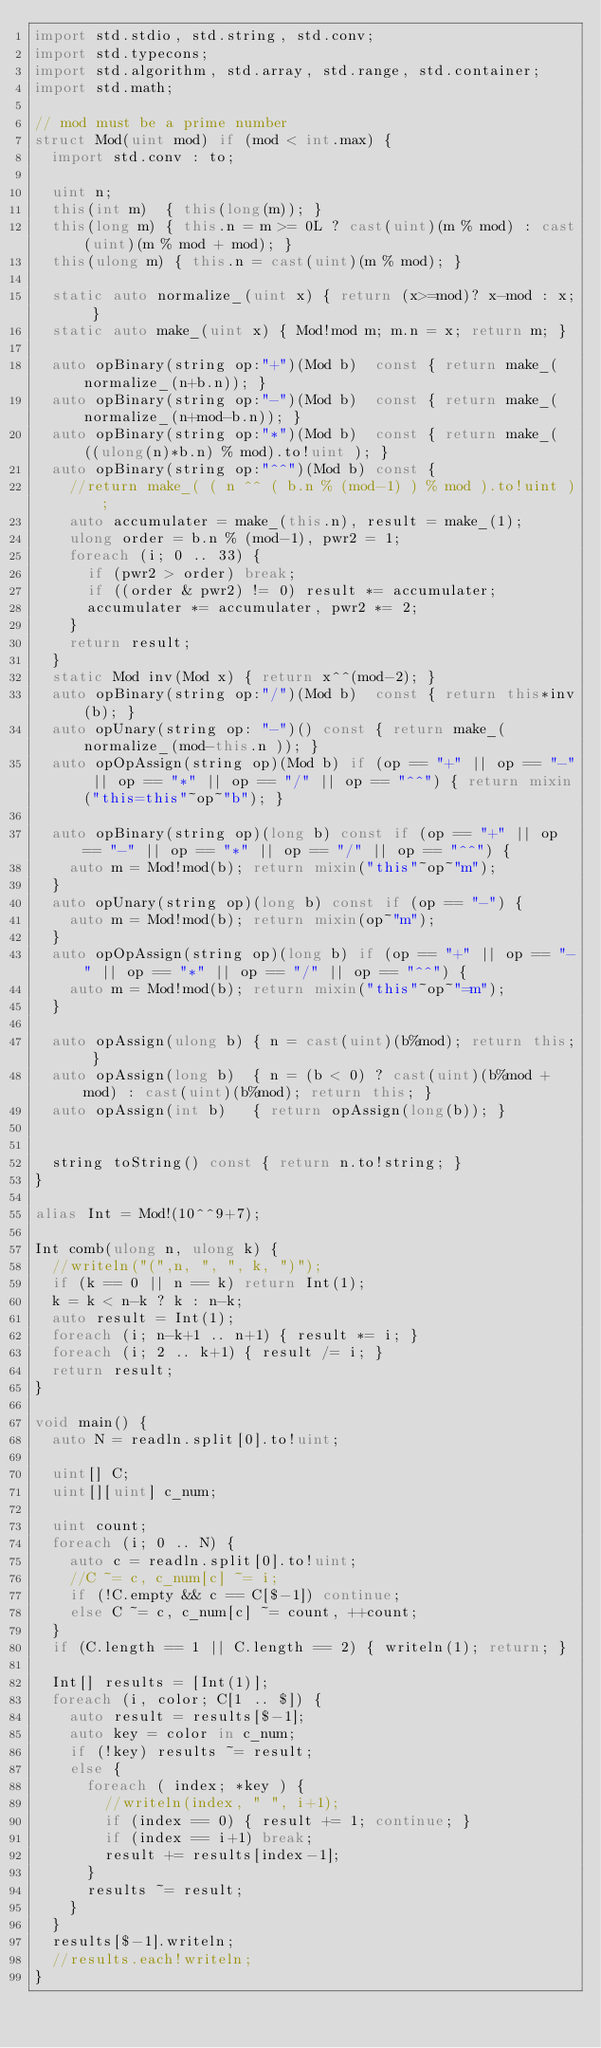<code> <loc_0><loc_0><loc_500><loc_500><_D_>import std.stdio, std.string, std.conv;
import std.typecons;
import std.algorithm, std.array, std.range, std.container;
import std.math;

// mod must be a prime number
struct Mod(uint mod) if (mod < int.max) {
	import std.conv : to;
	
	uint n;
	this(int m)  { this(long(m)); }
	this(long m) { this.n = m >= 0L ? cast(uint)(m % mod) : cast(uint)(m % mod + mod); }
	this(ulong m) { this.n = cast(uint)(m % mod); }
	
	static auto normalize_(uint x) { return (x>=mod)? x-mod : x; }
	static auto make_(uint x) { Mod!mod m; m.n = x; return m; }
	
	auto opBinary(string op:"+")(Mod b)  const { return make_(normalize_(n+b.n)); }
	auto opBinary(string op:"-")(Mod b)  const { return make_(normalize_(n+mod-b.n)); }
	auto opBinary(string op:"*")(Mod b)  const { return make_( ((ulong(n)*b.n) % mod).to!uint ); }
	auto opBinary(string op:"^^")(Mod b) const {
		//return make_( ( n ^^ ( b.n % (mod-1) ) % mod ).to!uint );
		auto accumulater = make_(this.n), result = make_(1);
		ulong order = b.n % (mod-1), pwr2 = 1;
		foreach (i; 0 .. 33) {
			if (pwr2 > order) break;
			if ((order & pwr2) != 0) result *= accumulater;
			accumulater *= accumulater, pwr2 *= 2;
		}
		return result;
	}
	static Mod inv(Mod x) { return x^^(mod-2); }
	auto opBinary(string op:"/")(Mod b)  const { return this*inv(b); }
	auto opUnary(string op: "-")() const { return make_(normalize_(mod-this.n )); }
	auto opOpAssign(string op)(Mod b) if (op == "+" || op == "-" || op == "*" || op == "/" || op == "^^") { return mixin("this=this"~op~"b"); }
	
	auto opBinary(string op)(long b) const if (op == "+" || op == "-" || op == "*" || op == "/" || op == "^^") {
		auto m = Mod!mod(b); return mixin("this"~op~"m");
	}
	auto opUnary(string op)(long b) const if (op == "-") {
		auto m = Mod!mod(b); return mixin(op~"m");
	}
	auto opOpAssign(string op)(long b) if (op == "+" || op == "-" || op == "*" || op == "/" || op == "^^") {
		auto m = Mod!mod(b); return mixin("this"~op~"=m");
	}
	
	auto opAssign(ulong b) { n = cast(uint)(b%mod); return this; }
	auto opAssign(long b)  { n = (b < 0) ? cast(uint)(b%mod + mod) : cast(uint)(b%mod); return this; }
	auto opAssign(int b)   { return opAssign(long(b)); }
	
	
	string toString() const { return n.to!string; }
}

alias Int = Mod!(10^^9+7);

Int comb(ulong n, ulong k) {
	//writeln("(",n, ", ", k, ")");
	if (k == 0 || n == k) return Int(1);
	k = k < n-k ? k : n-k;
	auto result = Int(1);
	foreach (i; n-k+1 .. n+1) { result *= i; }
	foreach (i; 2 .. k+1) { result /= i; }
	return result;
}

void main() {
	auto N = readln.split[0].to!uint;
	
	uint[] C;
	uint[][uint] c_num;
	
	uint count;
	foreach (i; 0 .. N) {
		auto c = readln.split[0].to!uint;
		//C ~= c, c_num[c] ~= i;
		if (!C.empty && c == C[$-1]) continue;
		else C ~= c, c_num[c] ~= count, ++count;
	}
	if (C.length == 1 || C.length == 2) { writeln(1); return; }
	
	Int[] results = [Int(1)];
	foreach (i, color; C[1 .. $]) {
		auto result = results[$-1];
		auto key = color in c_num;
		if (!key) results ~= result;
		else {
			foreach ( index; *key ) {
				//writeln(index, " ", i+1);
				if (index == 0) { result += 1; continue; }
				if (index == i+1) break;
				result += results[index-1];
			}
			results ~= result;
		}
	}
	results[$-1].writeln;
	//results.each!writeln;
}</code> 